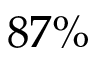Convert formula to latex. <formula><loc_0><loc_0><loc_500><loc_500>8 7 \%</formula> 